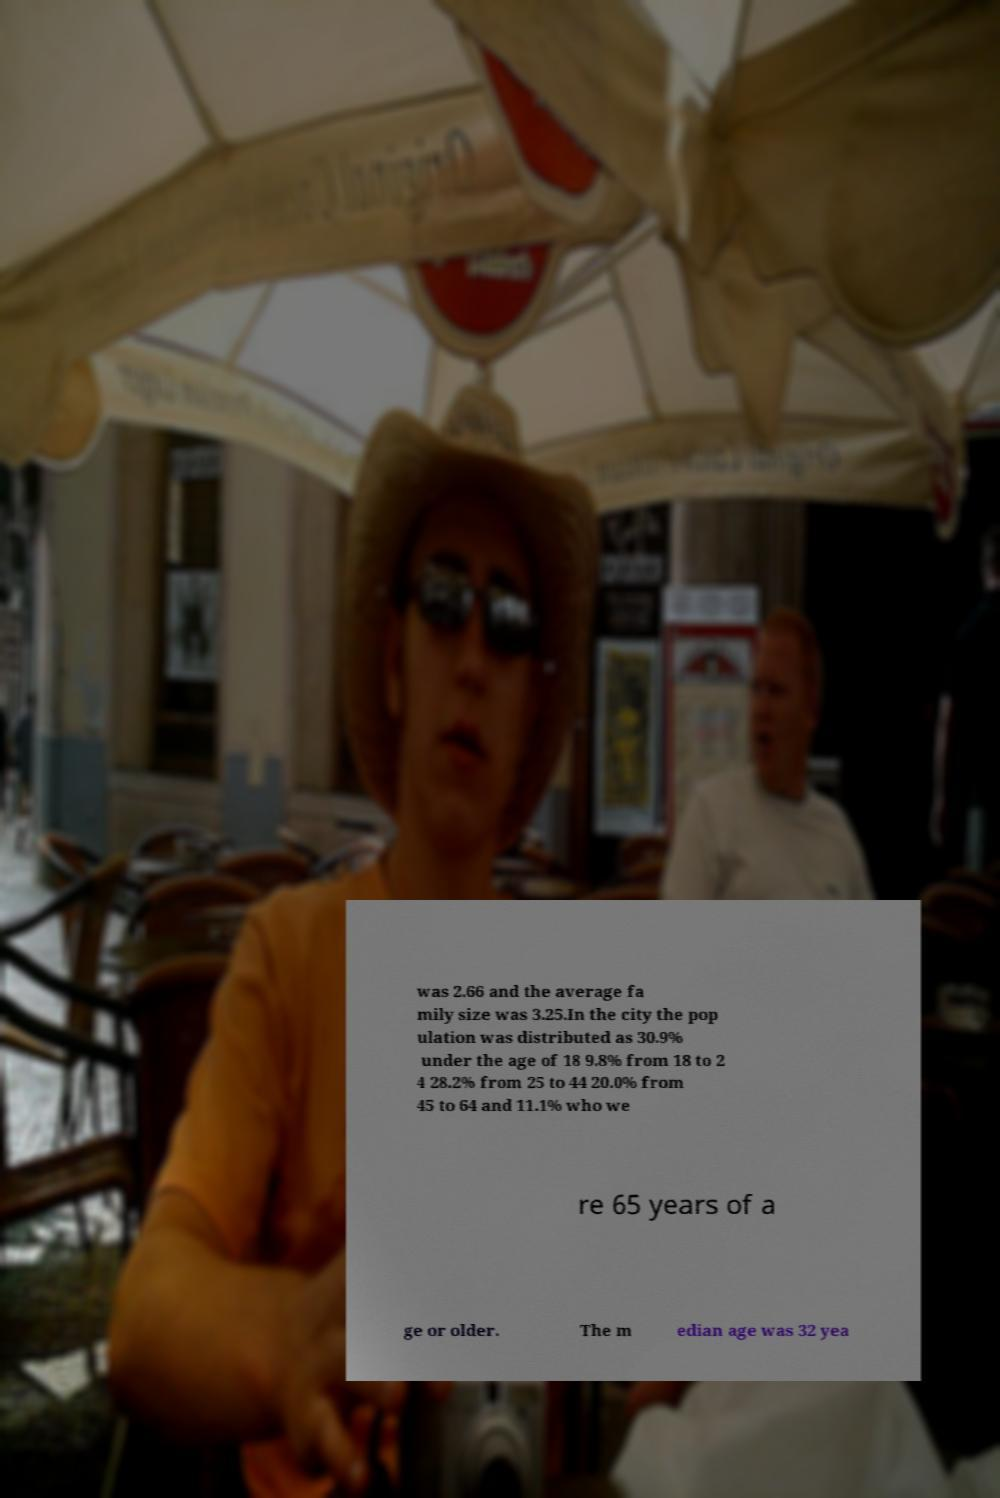Could you assist in decoding the text presented in this image and type it out clearly? was 2.66 and the average fa mily size was 3.25.In the city the pop ulation was distributed as 30.9% under the age of 18 9.8% from 18 to 2 4 28.2% from 25 to 44 20.0% from 45 to 64 and 11.1% who we re 65 years of a ge or older. The m edian age was 32 yea 